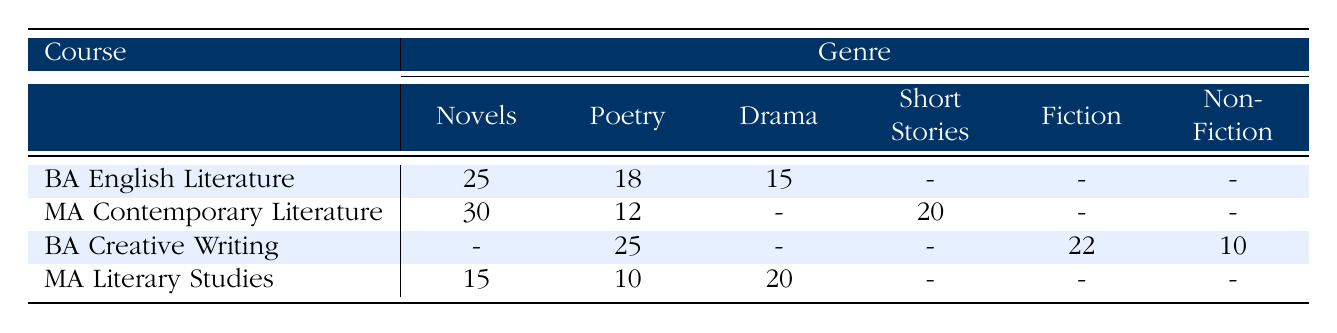What is the frequency of Poetry in the BA English Literature course? The table shows that in the BA English Literature course, the frequency for the Poetry genre is 18.
Answer: 18 What genre has the highest frequency in the MA Contemporary Literature course? In the MA Contemporary Literature course, the highest frequency is for Novels, listed as 30.
Answer: Novels Is there a genre that is not studied in the BA Creative Writing course? Looking at the BA Creative Writing row, we see that Short Stories and Non-Fiction do not have any frequency values, indicating that they are not studied.
Answer: Yes What is the total frequency of Drama studied across all courses? The frequencies for Drama in the different courses are: BA English Literature (15), MA Literary Studies (20), and MA Contemporary Literature (not listed, so 0). Adding these gives a total of 15 + 20 + 0 = 35.
Answer: 35 Which course studies more genres, the BA Creative Writing or the BA English Literature? The BA English Literature course studies Novels, Poetry, and Drama (3 genres), while the BA Creative Writing course studies Poetry, Fiction, and Non-Fiction (3 genres as well), so they study an equal number of genres.
Answer: Equal What is the average frequency of genres studied in the BA Creative Writing course? The BA Creative Writing course frequencies for the genres it covers are 25 (Poetry), 22 (Fiction), and 10 (Non-Fiction). Summing these gives 25 + 22 + 10 = 57, and since there are 3 genres, the average frequency is 57 / 3 = 19.
Answer: 19 Is the frequency of Novels higher in the MA Contemporary Literature course than in the MA Literary Studies course? The frequency of Novels in the MA Contemporary Literature course is 30, while in the MA Literary Studies course it is 15. Since 30 is greater than 15, the answer is yes.
Answer: Yes What is the frequency difference in Poetry between the BA Creative Writing and the MA Literary Studies courses? The frequency of Poetry in the BA Creative Writing course is 25, and in the MA Literary Studies course, it is 10. The difference is calculated by subtracting 10 from 25, which gives 15.
Answer: 15 